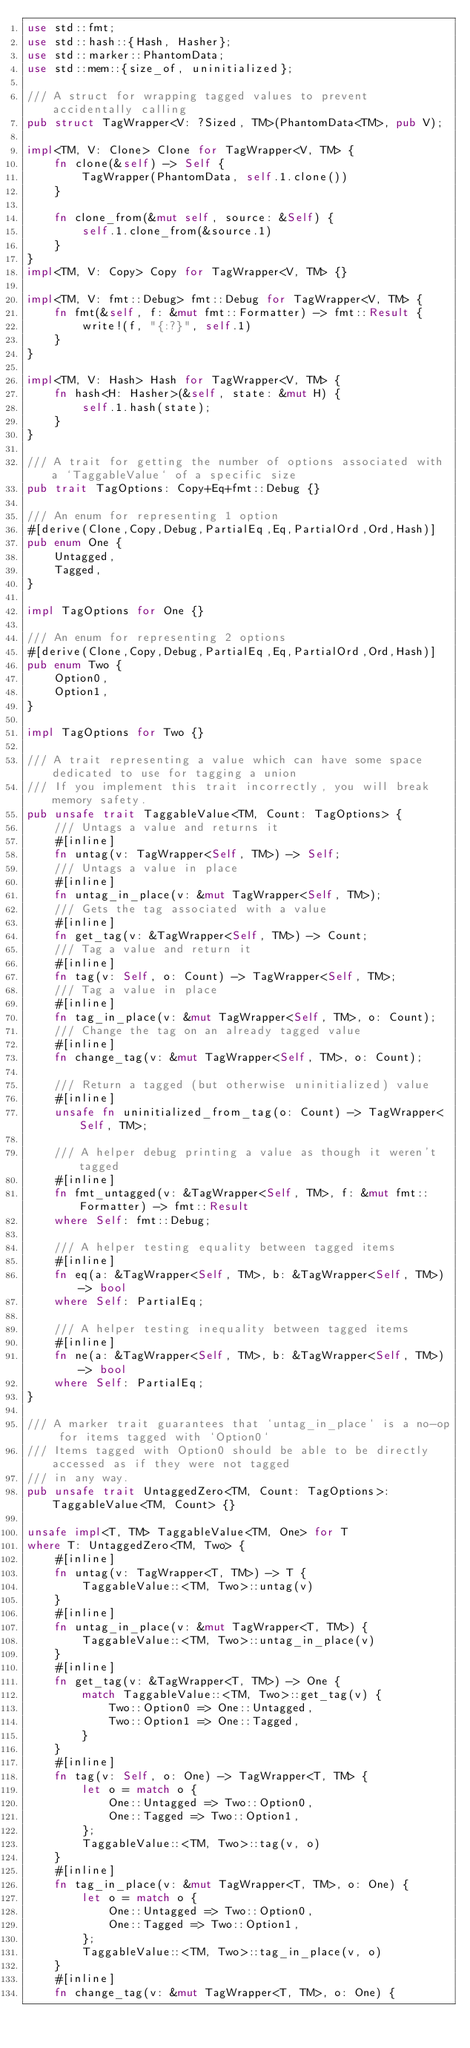<code> <loc_0><loc_0><loc_500><loc_500><_Rust_>use std::fmt;
use std::hash::{Hash, Hasher};
use std::marker::PhantomData;
use std::mem::{size_of, uninitialized};

/// A struct for wrapping tagged values to prevent accidentally calling
pub struct TagWrapper<V: ?Sized, TM>(PhantomData<TM>, pub V);

impl<TM, V: Clone> Clone for TagWrapper<V, TM> {
    fn clone(&self) -> Self {
        TagWrapper(PhantomData, self.1.clone())
    }

    fn clone_from(&mut self, source: &Self) {
        self.1.clone_from(&source.1)
    }
}
impl<TM, V: Copy> Copy for TagWrapper<V, TM> {}

impl<TM, V: fmt::Debug> fmt::Debug for TagWrapper<V, TM> {
    fn fmt(&self, f: &mut fmt::Formatter) -> fmt::Result {
        write!(f, "{:?}", self.1)
    }
}

impl<TM, V: Hash> Hash for TagWrapper<V, TM> {
    fn hash<H: Hasher>(&self, state: &mut H) {
        self.1.hash(state);
    }
}

/// A trait for getting the number of options associated with a `TaggableValue` of a specific size
pub trait TagOptions: Copy+Eq+fmt::Debug {}

/// An enum for representing 1 option
#[derive(Clone,Copy,Debug,PartialEq,Eq,PartialOrd,Ord,Hash)]
pub enum One {
    Untagged,
    Tagged,
}

impl TagOptions for One {}

/// An enum for representing 2 options
#[derive(Clone,Copy,Debug,PartialEq,Eq,PartialOrd,Ord,Hash)]
pub enum Two {
    Option0,
    Option1,
}

impl TagOptions for Two {}

/// A trait representing a value which can have some space dedicated to use for tagging a union
/// If you implement this trait incorrectly, you will break memory safety.
pub unsafe trait TaggableValue<TM, Count: TagOptions> {
    /// Untags a value and returns it
    #[inline]
    fn untag(v: TagWrapper<Self, TM>) -> Self;
    /// Untags a value in place
    #[inline]
    fn untag_in_place(v: &mut TagWrapper<Self, TM>);
    /// Gets the tag associated with a value
    #[inline]
    fn get_tag(v: &TagWrapper<Self, TM>) -> Count;
    /// Tag a value and return it
    #[inline]
    fn tag(v: Self, o: Count) -> TagWrapper<Self, TM>;
    /// Tag a value in place
    #[inline]
    fn tag_in_place(v: &mut TagWrapper<Self, TM>, o: Count);
    /// Change the tag on an already tagged value
    #[inline]
    fn change_tag(v: &mut TagWrapper<Self, TM>, o: Count);

    /// Return a tagged (but otherwise uninitialized) value
    #[inline]
    unsafe fn uninitialized_from_tag(o: Count) -> TagWrapper<Self, TM>;

    /// A helper debug printing a value as though it weren't tagged
    #[inline]
    fn fmt_untagged(v: &TagWrapper<Self, TM>, f: &mut fmt::Formatter) -> fmt::Result
    where Self: fmt::Debug;

    /// A helper testing equality between tagged items
    #[inline]
    fn eq(a: &TagWrapper<Self, TM>, b: &TagWrapper<Self, TM>) -> bool
    where Self: PartialEq;

    /// A helper testing inequality between tagged items
    #[inline]
    fn ne(a: &TagWrapper<Self, TM>, b: &TagWrapper<Self, TM>) -> bool
    where Self: PartialEq;
}

/// A marker trait guarantees that `untag_in_place` is a no-op for items tagged with `Option0`
/// Items tagged with Option0 should be able to be directly accessed as if they were not tagged
/// in any way.
pub unsafe trait UntaggedZero<TM, Count: TagOptions>: TaggableValue<TM, Count> {}

unsafe impl<T, TM> TaggableValue<TM, One> for T
where T: UntaggedZero<TM, Two> {
    #[inline]
    fn untag(v: TagWrapper<T, TM>) -> T {
        TaggableValue::<TM, Two>::untag(v)
    }
    #[inline]
    fn untag_in_place(v: &mut TagWrapper<T, TM>) {
        TaggableValue::<TM, Two>::untag_in_place(v)
    }
    #[inline]
    fn get_tag(v: &TagWrapper<T, TM>) -> One {
        match TaggableValue::<TM, Two>::get_tag(v) {
            Two::Option0 => One::Untagged,
            Two::Option1 => One::Tagged,
        }
    }
    #[inline]
    fn tag(v: Self, o: One) -> TagWrapper<T, TM> {
        let o = match o {
            One::Untagged => Two::Option0,
            One::Tagged => Two::Option1,
        };
        TaggableValue::<TM, Two>::tag(v, o)
    }
    #[inline]
    fn tag_in_place(v: &mut TagWrapper<T, TM>, o: One) {
        let o = match o {
            One::Untagged => Two::Option0,
            One::Tagged => Two::Option1,
        };
        TaggableValue::<TM, Two>::tag_in_place(v, o)
    }
    #[inline]
    fn change_tag(v: &mut TagWrapper<T, TM>, o: One) {</code> 